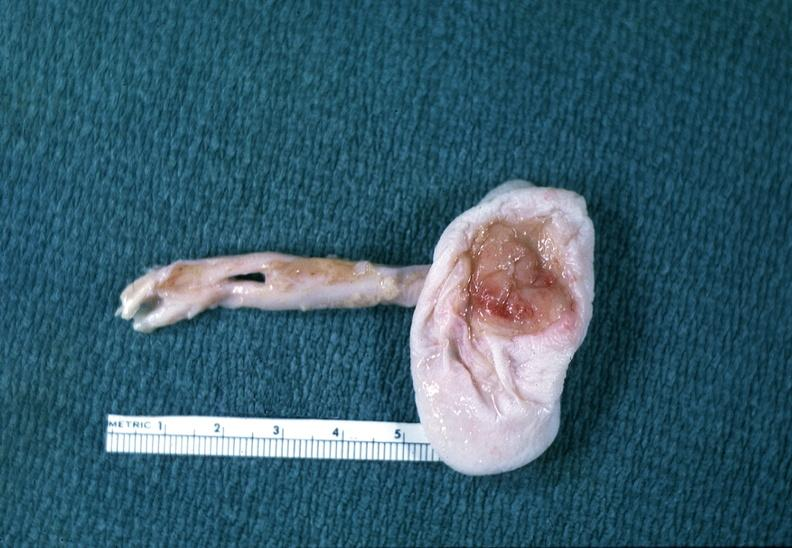s polysplenia present?
Answer the question using a single word or phrase. No 